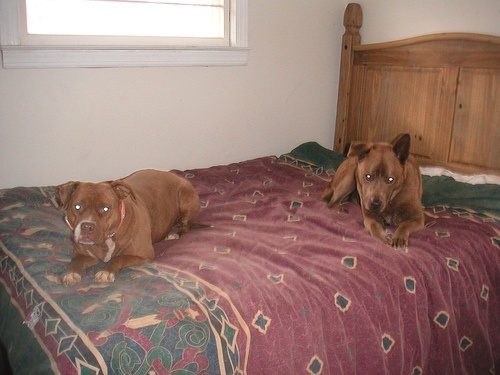Describe the objects in this image and their specific colors. I can see bed in darkgray, brown, gray, maroon, and black tones, dog in darkgray and brown tones, and dog in darkgray, maroon, and brown tones in this image. 